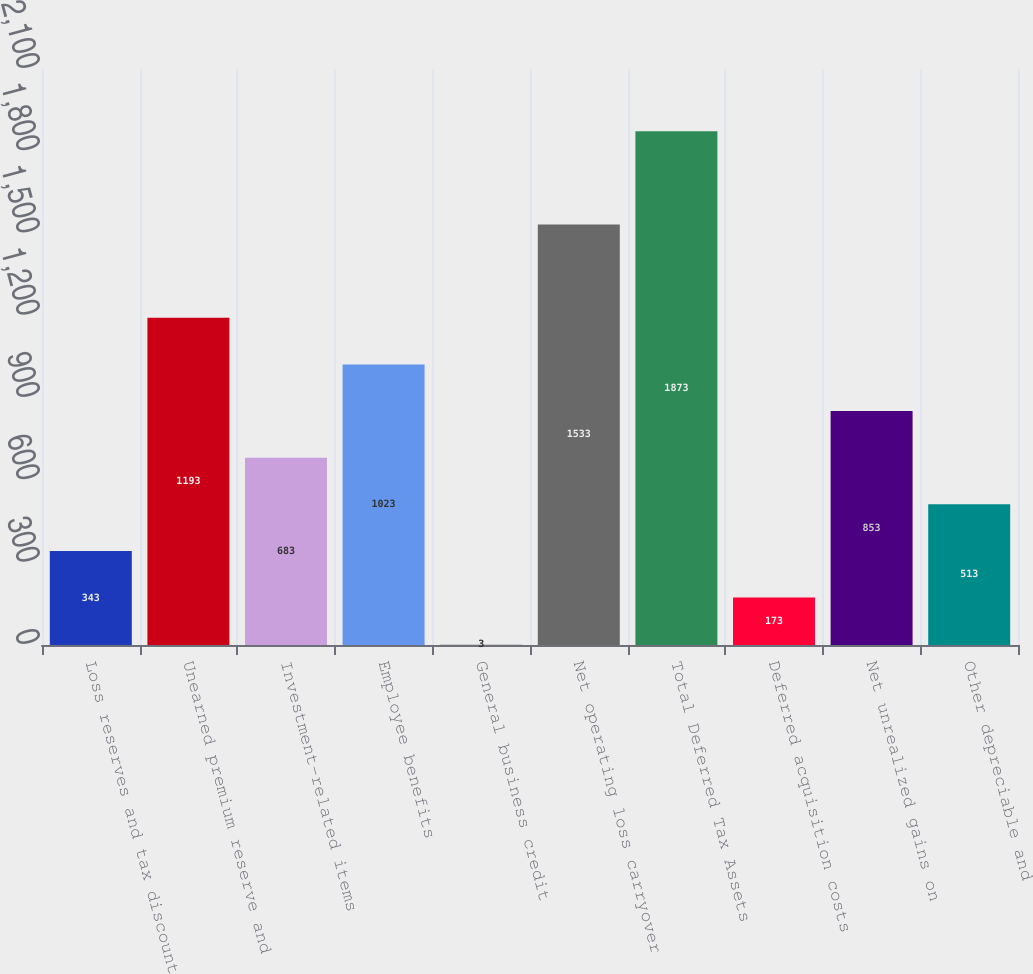Convert chart to OTSL. <chart><loc_0><loc_0><loc_500><loc_500><bar_chart><fcel>Loss reserves and tax discount<fcel>Unearned premium reserve and<fcel>Investment-related items<fcel>Employee benefits<fcel>General business credit<fcel>Net operating loss carryover<fcel>Total Deferred Tax Assets<fcel>Deferred acquisition costs<fcel>Net unrealized gains on<fcel>Other depreciable and<nl><fcel>343<fcel>1193<fcel>683<fcel>1023<fcel>3<fcel>1533<fcel>1873<fcel>173<fcel>853<fcel>513<nl></chart> 